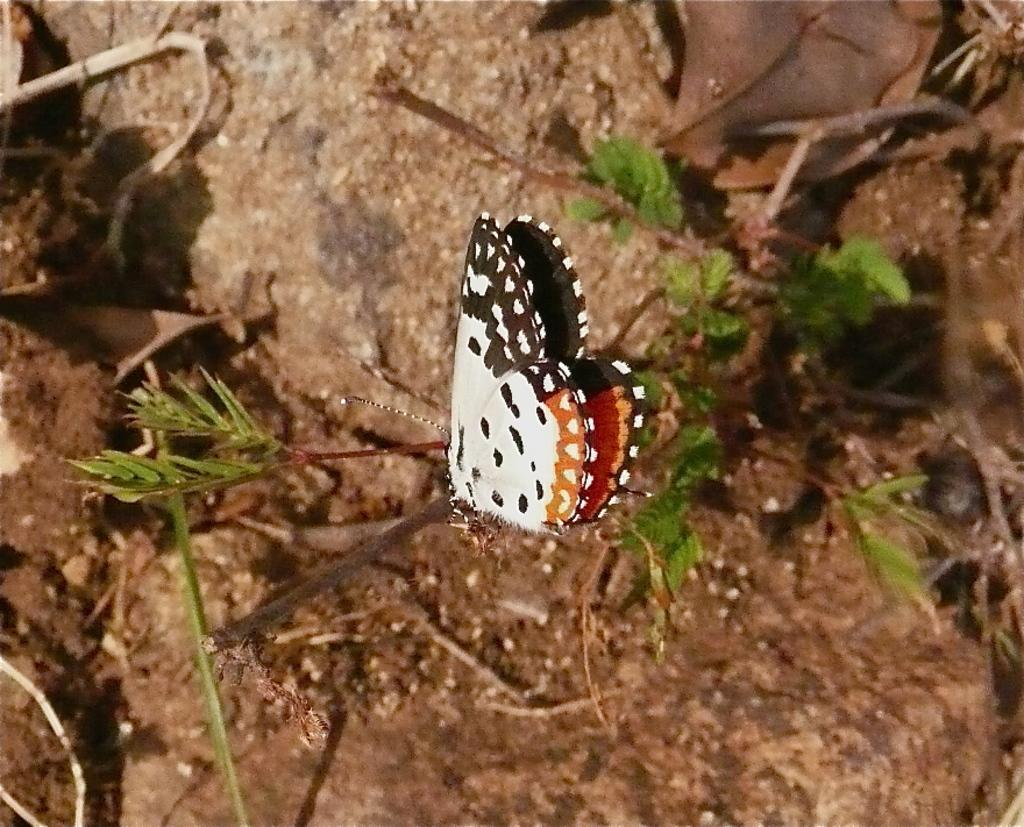What is in the foreground of the image? There are butterflies in the foreground of the image. What can be seen in the background of the image? There is a rock in the background of the image. What does the father taste like in the image? There is no father present in the image, so it is not possible to determine what he might taste like. 